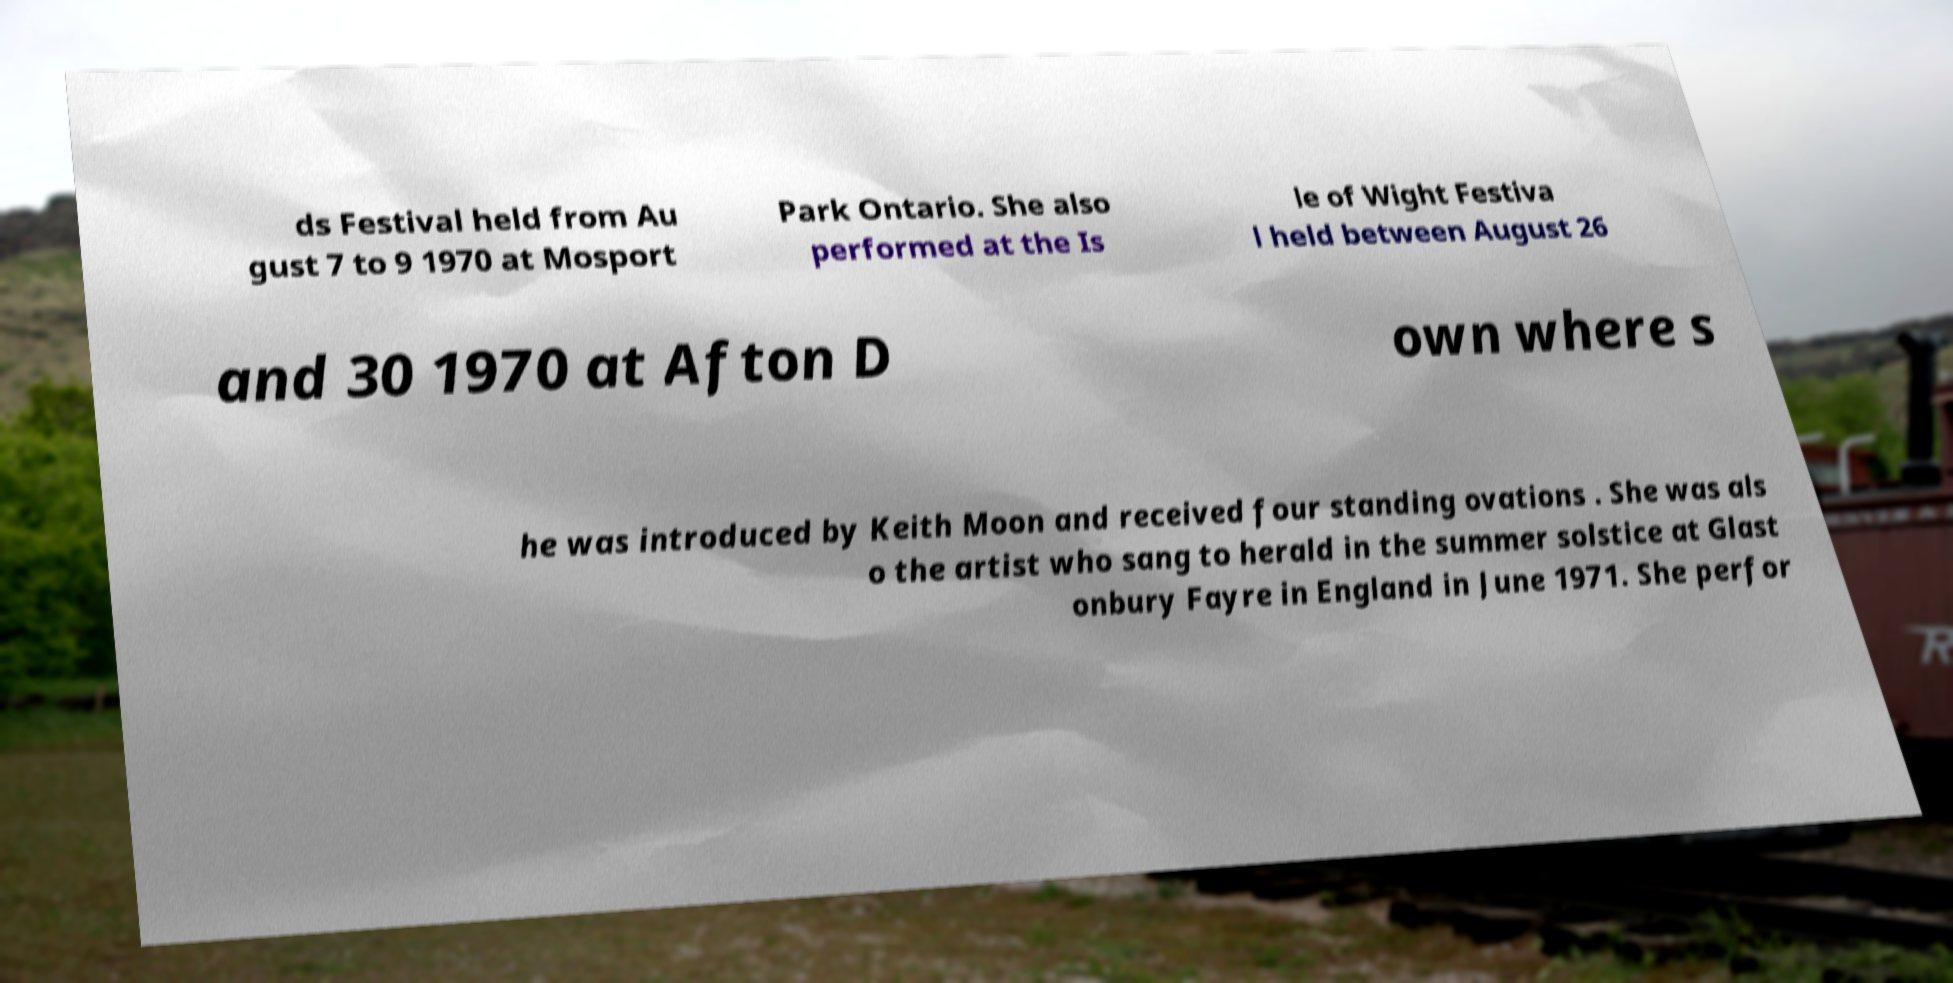Can you read and provide the text displayed in the image?This photo seems to have some interesting text. Can you extract and type it out for me? ds Festival held from Au gust 7 to 9 1970 at Mosport Park Ontario. She also performed at the Is le of Wight Festiva l held between August 26 and 30 1970 at Afton D own where s he was introduced by Keith Moon and received four standing ovations . She was als o the artist who sang to herald in the summer solstice at Glast onbury Fayre in England in June 1971. She perfor 